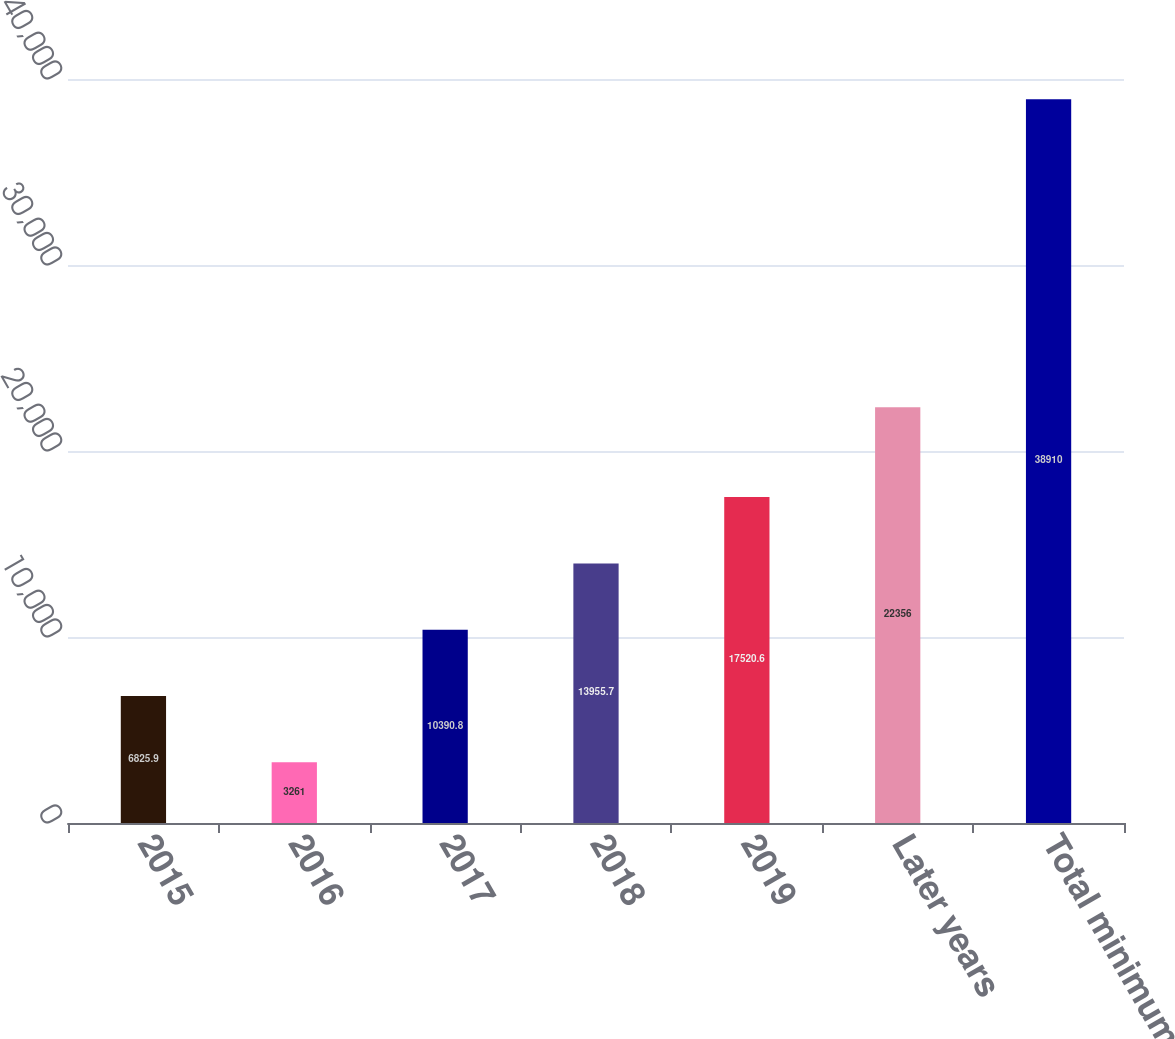Convert chart to OTSL. <chart><loc_0><loc_0><loc_500><loc_500><bar_chart><fcel>2015<fcel>2016<fcel>2017<fcel>2018<fcel>2019<fcel>Later years<fcel>Total minimum rental<nl><fcel>6825.9<fcel>3261<fcel>10390.8<fcel>13955.7<fcel>17520.6<fcel>22356<fcel>38910<nl></chart> 